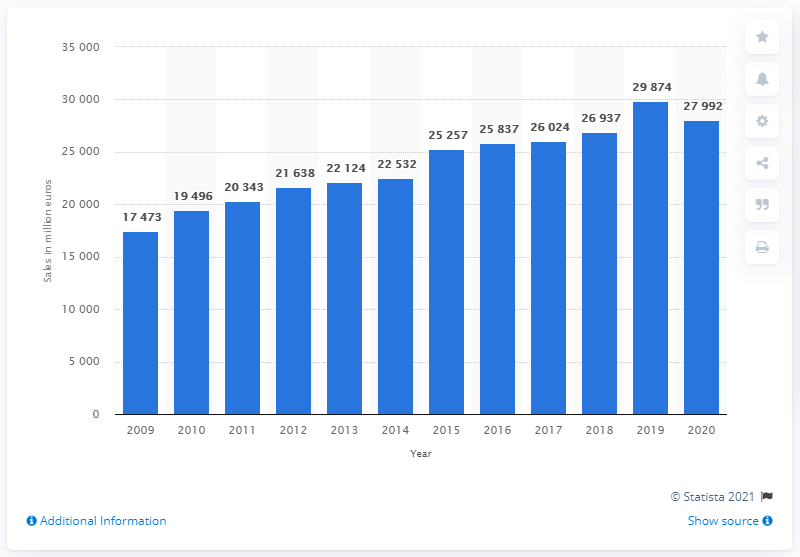Specify some key components in this picture. The consolidated sales of L'Oréal Group in 2020 were 27,992. In 2020, the Lâ€TMOral Group's consolidated sales fell by a significant amount, amounting to 27,992. 